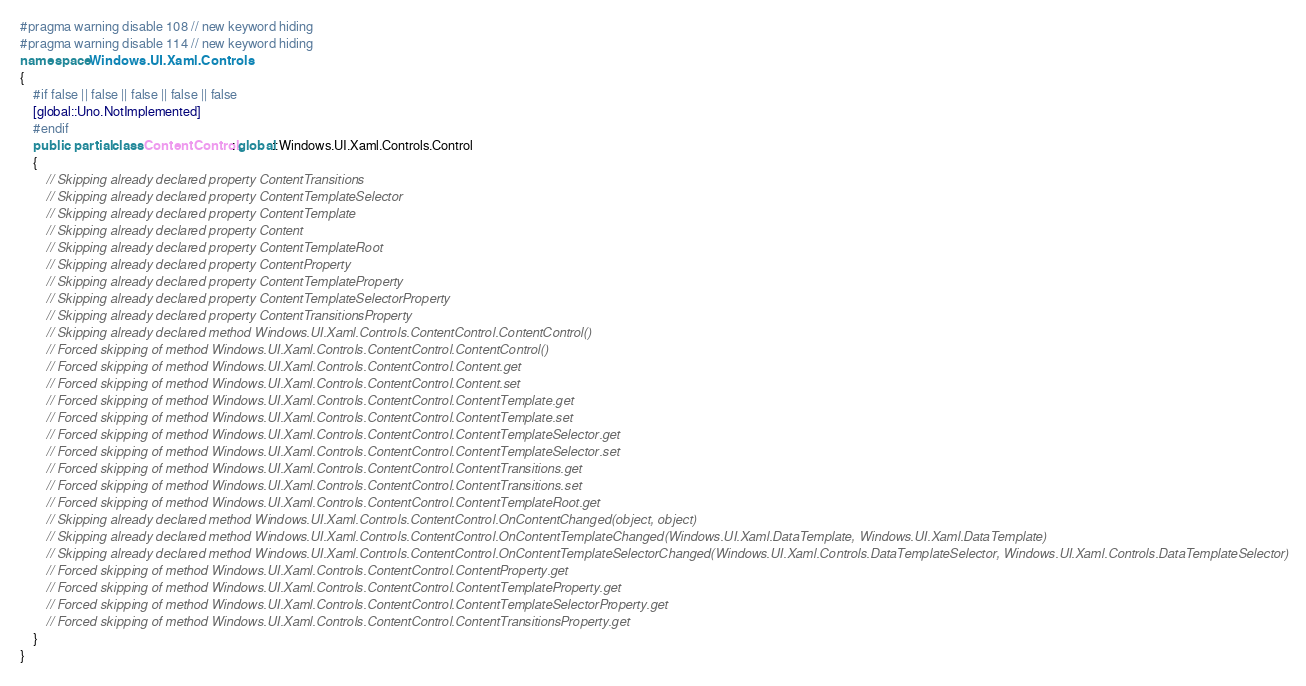<code> <loc_0><loc_0><loc_500><loc_500><_C#_>#pragma warning disable 108 // new keyword hiding
#pragma warning disable 114 // new keyword hiding
namespace Windows.UI.Xaml.Controls
{
	#if false || false || false || false || false
	[global::Uno.NotImplemented]
	#endif
	public  partial class ContentControl : global::Windows.UI.Xaml.Controls.Control
	{
		// Skipping already declared property ContentTransitions
		// Skipping already declared property ContentTemplateSelector
		// Skipping already declared property ContentTemplate
		// Skipping already declared property Content
		// Skipping already declared property ContentTemplateRoot
		// Skipping already declared property ContentProperty
		// Skipping already declared property ContentTemplateProperty
		// Skipping already declared property ContentTemplateSelectorProperty
		// Skipping already declared property ContentTransitionsProperty
		// Skipping already declared method Windows.UI.Xaml.Controls.ContentControl.ContentControl()
		// Forced skipping of method Windows.UI.Xaml.Controls.ContentControl.ContentControl()
		// Forced skipping of method Windows.UI.Xaml.Controls.ContentControl.Content.get
		// Forced skipping of method Windows.UI.Xaml.Controls.ContentControl.Content.set
		// Forced skipping of method Windows.UI.Xaml.Controls.ContentControl.ContentTemplate.get
		// Forced skipping of method Windows.UI.Xaml.Controls.ContentControl.ContentTemplate.set
		// Forced skipping of method Windows.UI.Xaml.Controls.ContentControl.ContentTemplateSelector.get
		// Forced skipping of method Windows.UI.Xaml.Controls.ContentControl.ContentTemplateSelector.set
		// Forced skipping of method Windows.UI.Xaml.Controls.ContentControl.ContentTransitions.get
		// Forced skipping of method Windows.UI.Xaml.Controls.ContentControl.ContentTransitions.set
		// Forced skipping of method Windows.UI.Xaml.Controls.ContentControl.ContentTemplateRoot.get
		// Skipping already declared method Windows.UI.Xaml.Controls.ContentControl.OnContentChanged(object, object)
		// Skipping already declared method Windows.UI.Xaml.Controls.ContentControl.OnContentTemplateChanged(Windows.UI.Xaml.DataTemplate, Windows.UI.Xaml.DataTemplate)
		// Skipping already declared method Windows.UI.Xaml.Controls.ContentControl.OnContentTemplateSelectorChanged(Windows.UI.Xaml.Controls.DataTemplateSelector, Windows.UI.Xaml.Controls.DataTemplateSelector)
		// Forced skipping of method Windows.UI.Xaml.Controls.ContentControl.ContentProperty.get
		// Forced skipping of method Windows.UI.Xaml.Controls.ContentControl.ContentTemplateProperty.get
		// Forced skipping of method Windows.UI.Xaml.Controls.ContentControl.ContentTemplateSelectorProperty.get
		// Forced skipping of method Windows.UI.Xaml.Controls.ContentControl.ContentTransitionsProperty.get
	}
}
</code> 